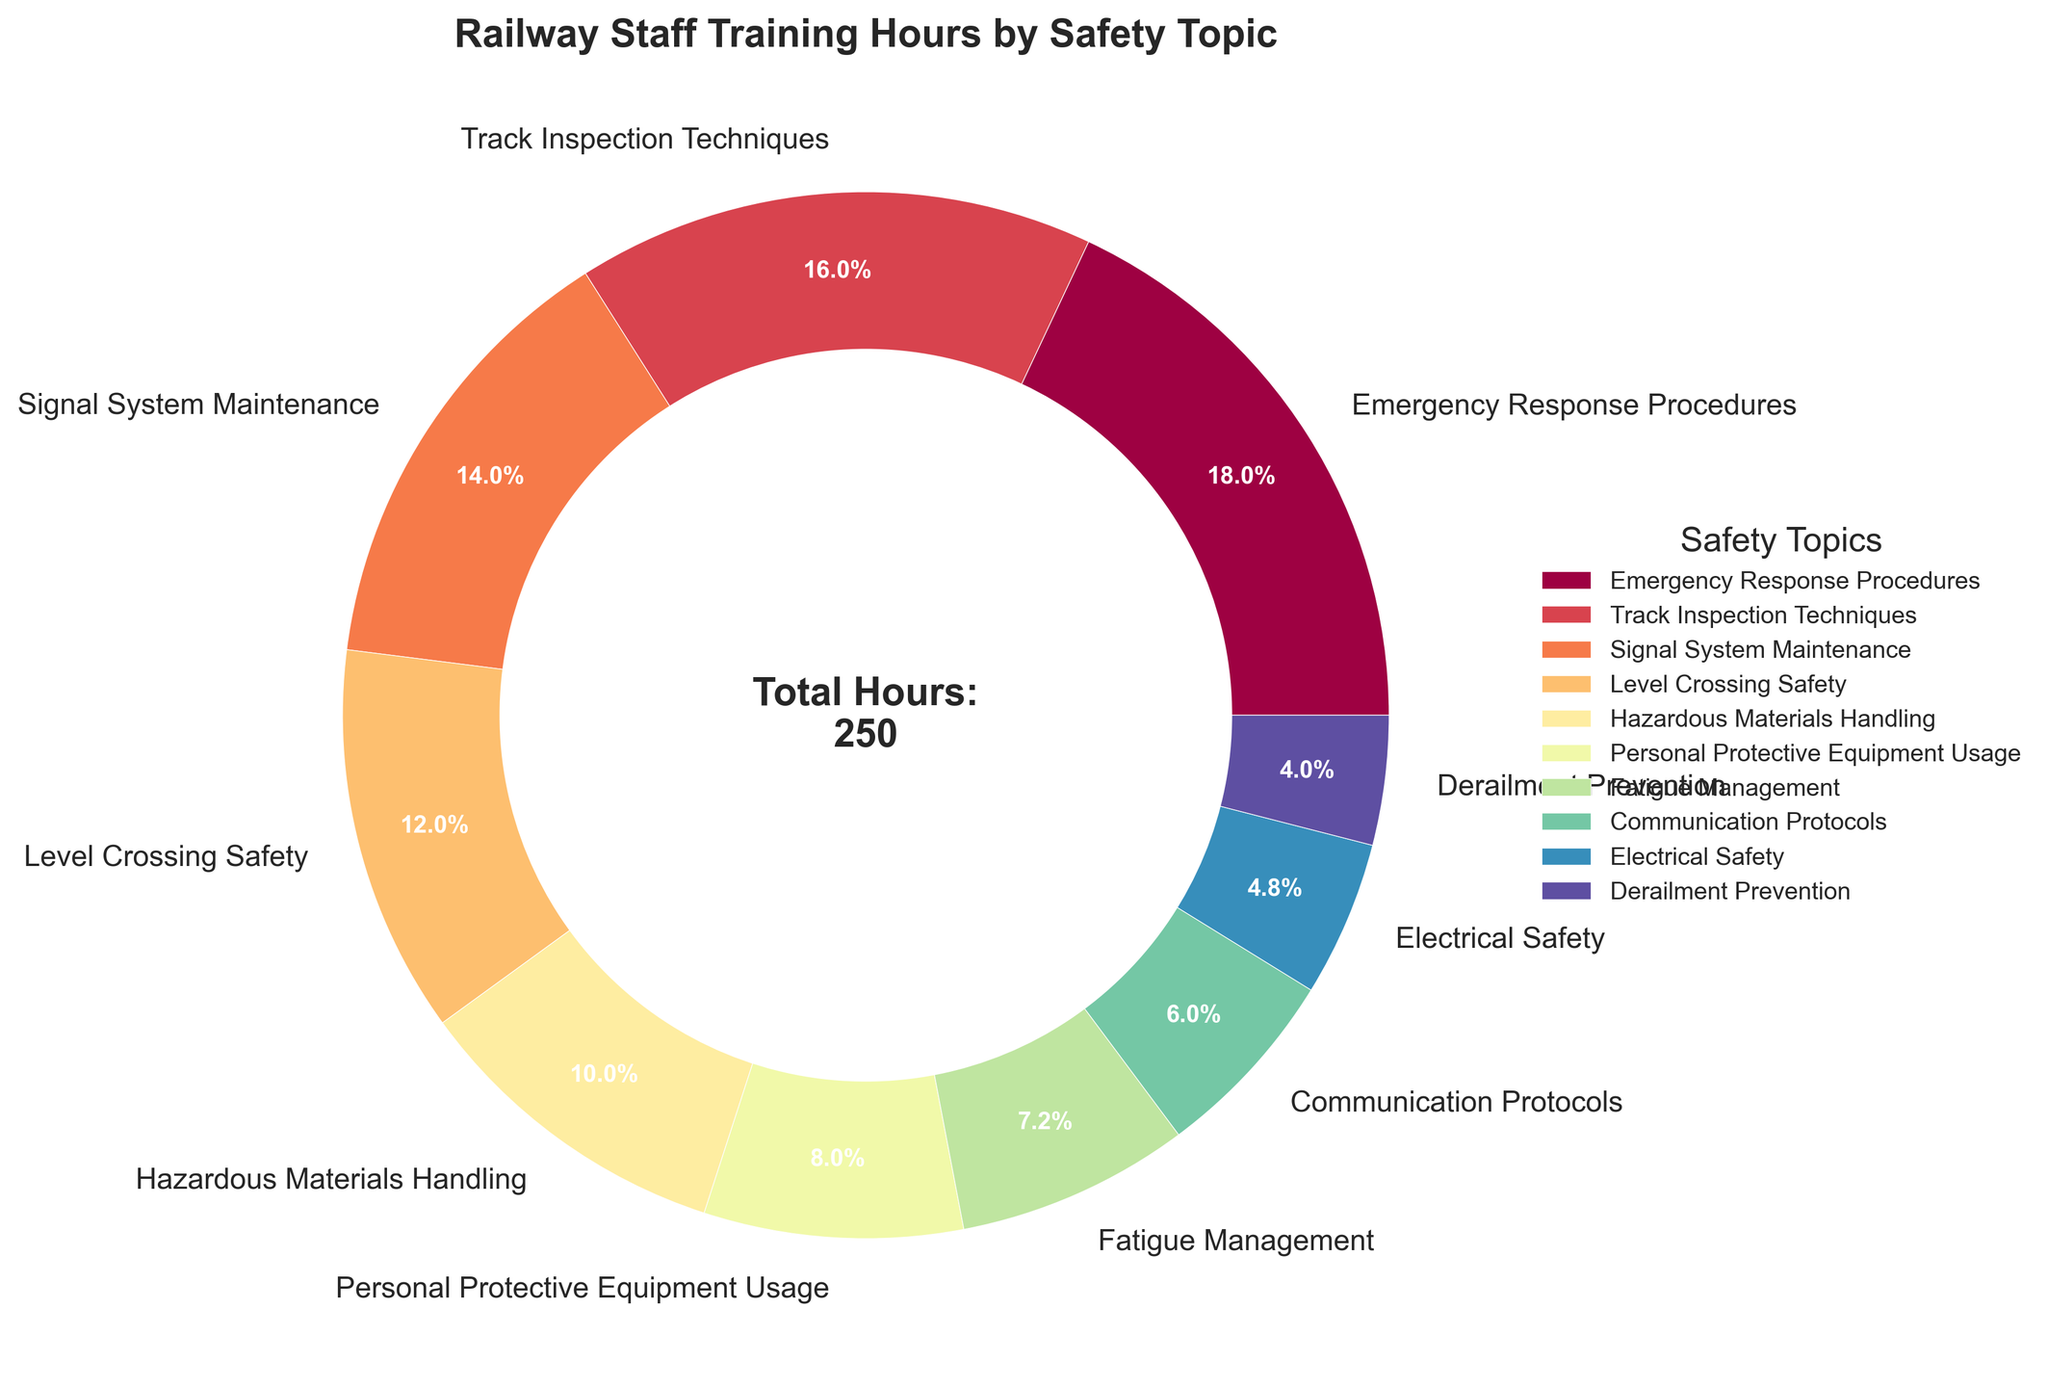How many more hours are allocated to Emergency Response Procedures compared to Derailment Prevention? To calculate this, subtract the hours allocated to Derailment Prevention (10) from those allocated to Emergency Response Procedures (45). Hence, 45 - 10 = 35.
Answer: 35 What percentage of the total training hours is dedicated to Hazardous Materials Handling and Fatigue Management combined? First, sum the hours for Hazardous Materials Handling (25) and Fatigue Management (18), which gives 43. Then, calculate the total hours from all topics, which is 250. The combined percentage is (43/250) * 100 = 17.2%.
Answer: 17.2% Which safety topic has the lowest allocation of training hours? By observing the visual representation of the data, we see that Derailment Prevention has the smallest segment in the pie chart, indicating it has the lowest allocated hours.
Answer: Derailment Prevention Is the allocation of training hours to Signal System Maintenance greater than to Level Crossing Safety? Yes, Signal System Maintenance has 35 training hours while Level Crossing Safety has 30, thus the allocation to Signal System Maintenance is greater.
Answer: Yes What is the combined total of training hours for Communication Protocols, Electrical Safety, and Derailment Prevention? Add the hours for Communication Protocols (15), Electrical Safety (12), and Derailment Prevention (10). That is, 15 + 12 + 10 = 37.
Answer: 37 How does the training allocation for Track Inspection Techniques compare to that for Personal Protective Equipment Usage? Track Inspection Techniques has 40 hours and Personal Protective Equipment Usage has 20 hours. 40 is twice as much as 20.
Answer: Twice as much Name the safety topic with a middle range of allocated hours and specify the total training hours. By observing the visual distribution, Level Crossing Safety appears to be in the middle range with 30 training hours.
Answer: Level Crossing Safety, 30 What's the cumulative percentage of training hours dedicated to the top three topics? The top three topics are Emergency Response Procedures (45), Track Inspection Techniques (40), and Signal System Maintenance (35). Their combined hours are 45 + 40 + 35 = 120. The cumulative percentage is (120/250) * 100 = 48%.
Answer: 48% What color represents the section for Emergency Response Procedures? By observing the colors used in the pie chart, the section for Emergency Response Procedures can be identified and described.
Answer: [Specify the color based on visual inspection] Compare the visual size of the slices for Personal Protective Equipment Usage and Fatigue Management. Based on the pie chart, the slice representing Personal Protective Equipment Usage appears slightly larger than the one for Fatigue Management.
Answer: Slightly larger 